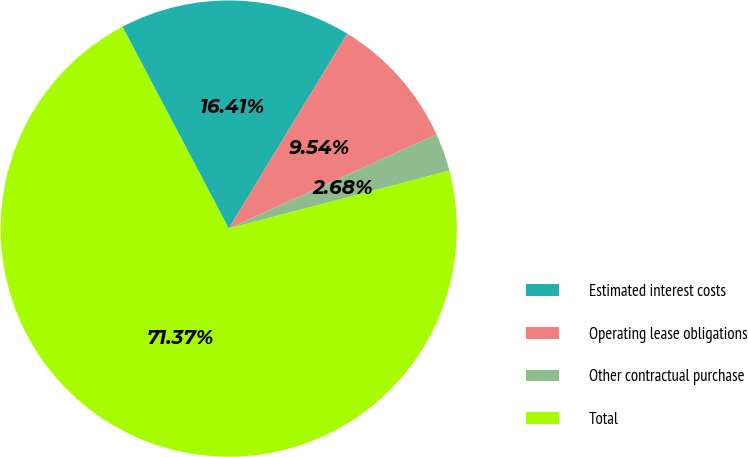Convert chart. <chart><loc_0><loc_0><loc_500><loc_500><pie_chart><fcel>Estimated interest costs<fcel>Operating lease obligations<fcel>Other contractual purchase<fcel>Total<nl><fcel>16.41%<fcel>9.54%<fcel>2.68%<fcel>71.37%<nl></chart> 